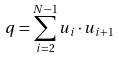<formula> <loc_0><loc_0><loc_500><loc_500>q = \sum _ { i = 2 } ^ { N - 1 } { u } _ { i } \cdot { u } _ { i + 1 }</formula> 